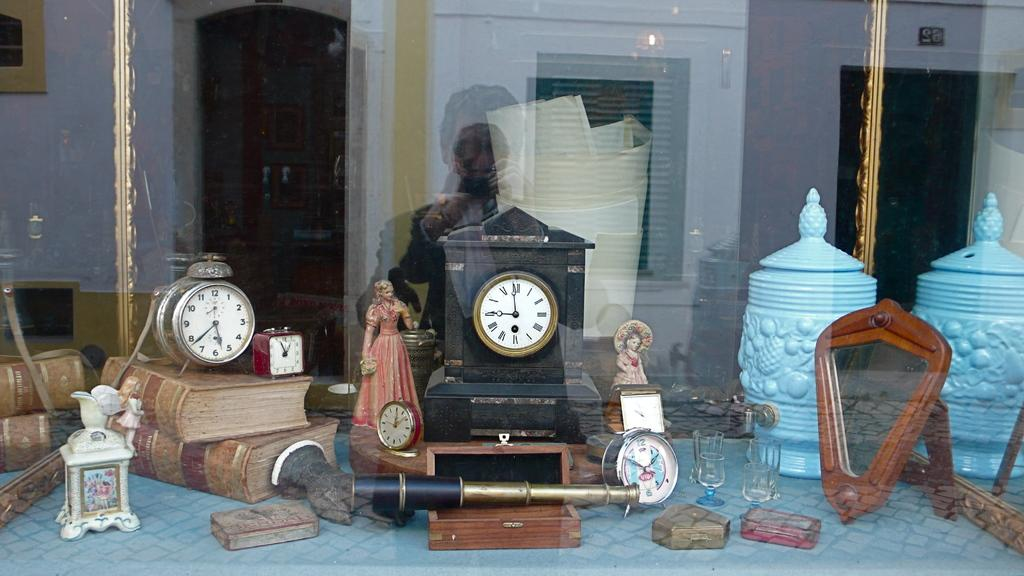<image>
Create a compact narrative representing the image presented. Several clocks, including one imprinted with the word Nevada, adorn a window display. 